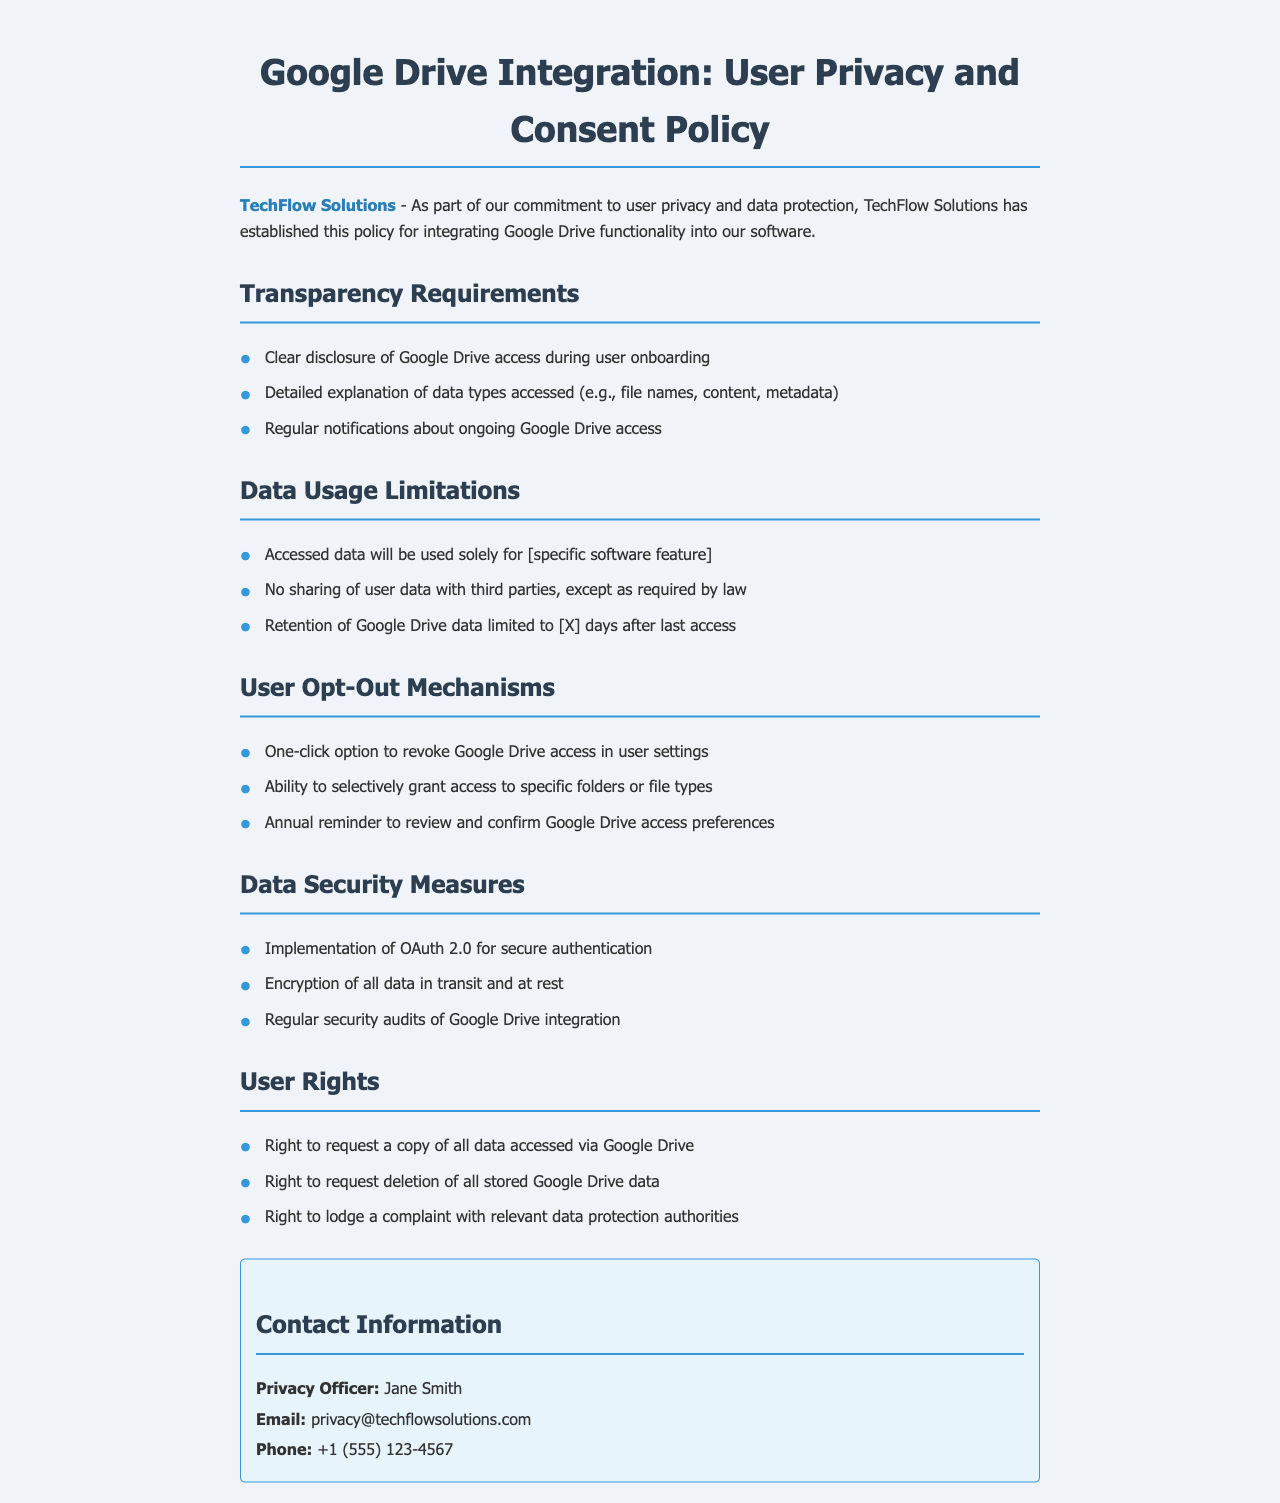What is the name of the company establishing the policy? The company name mentioned in the document is TechFlow Solutions.
Answer: TechFlow Solutions Who is the Privacy Officer? The Privacy Officer responsible for this policy is mentioned in the contact section of the document.
Answer: Jane Smith What is the data retention period after the last access? The document specifies a limitation on retention of Google Drive data, but the exact number of days is indicated as a placeholder.
Answer: [X] days What type of access option is provided for users in settings? The document mentions a specific feature available to users that allows them to control access.
Answer: One-click option What is the purpose of accessing Google Drive data? The document states that accessed data will only be utilized for a specific function within the software.
Answer: [specific software feature] What security measure is mentioned for authentication? The policy outlines a specific framework used for secure authentication of user access.
Answer: OAuth 2.0 What is the right available to users regarding their data? The document provides specific rights given to users concerning their data accessed through Google Drive.
Answer: Right to request deletion How often will users be reminded to review access preferences? The policy includes a mechanism for reminders that occur at a specified frequency.
Answer: Annual What kind of encryption is mentioned in the document? The document states security measures taken to protect data both during transmission and storage, specifically mentioning encryption.
Answer: Encryption of all data 